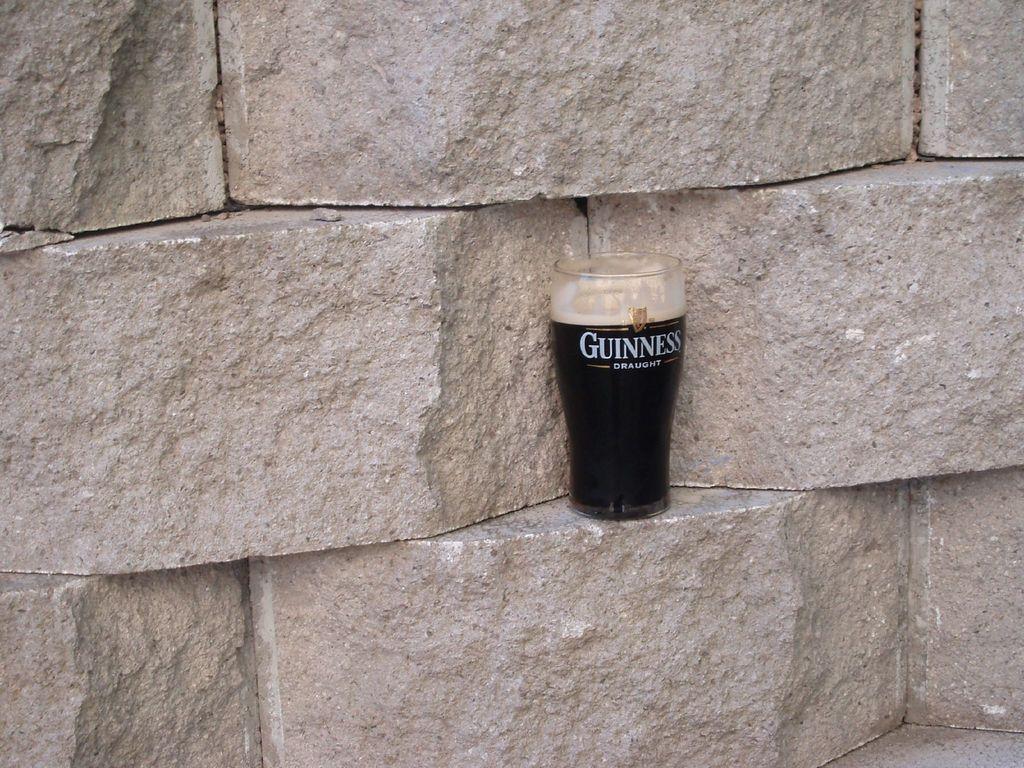What kind of beer is shown?
Your answer should be compact. Guinness. 